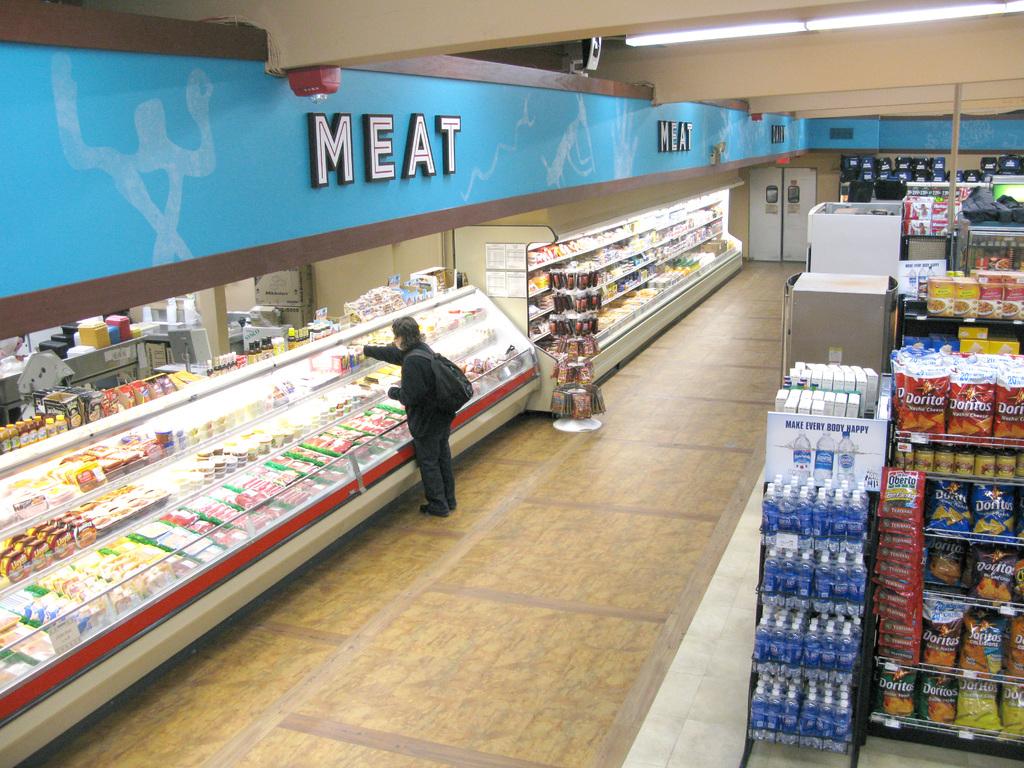What food section is featured on the photo?
Make the answer very short. Meat. Are those doritos?
Keep it short and to the point. Yes. 